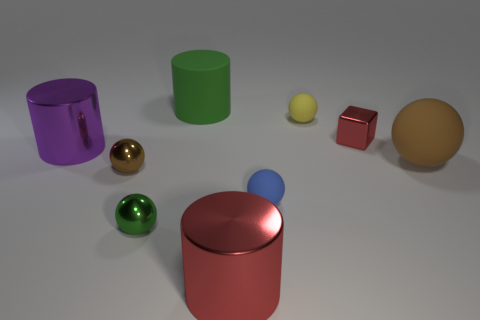There is a cylinder that is the same color as the tiny block; what is its material?
Ensure brevity in your answer.  Metal. The metal cylinder that is the same color as the metallic block is what size?
Your answer should be compact. Large. How many other things are there of the same shape as the large brown rubber thing?
Keep it short and to the point. 4. Do the tiny metallic object in front of the blue ball and the big object that is on the left side of the matte cylinder have the same shape?
Keep it short and to the point. No. Is there anything else that has the same material as the big brown thing?
Your response must be concise. Yes. What is the material of the tiny yellow thing?
Offer a terse response. Rubber. What material is the brown object on the left side of the large brown object?
Offer a very short reply. Metal. Is there any other thing that has the same color as the small shiny block?
Provide a succinct answer. Yes. What size is the yellow ball that is made of the same material as the blue sphere?
Provide a short and direct response. Small. How many large things are brown metal spheres or blue matte balls?
Your answer should be very brief. 0. 